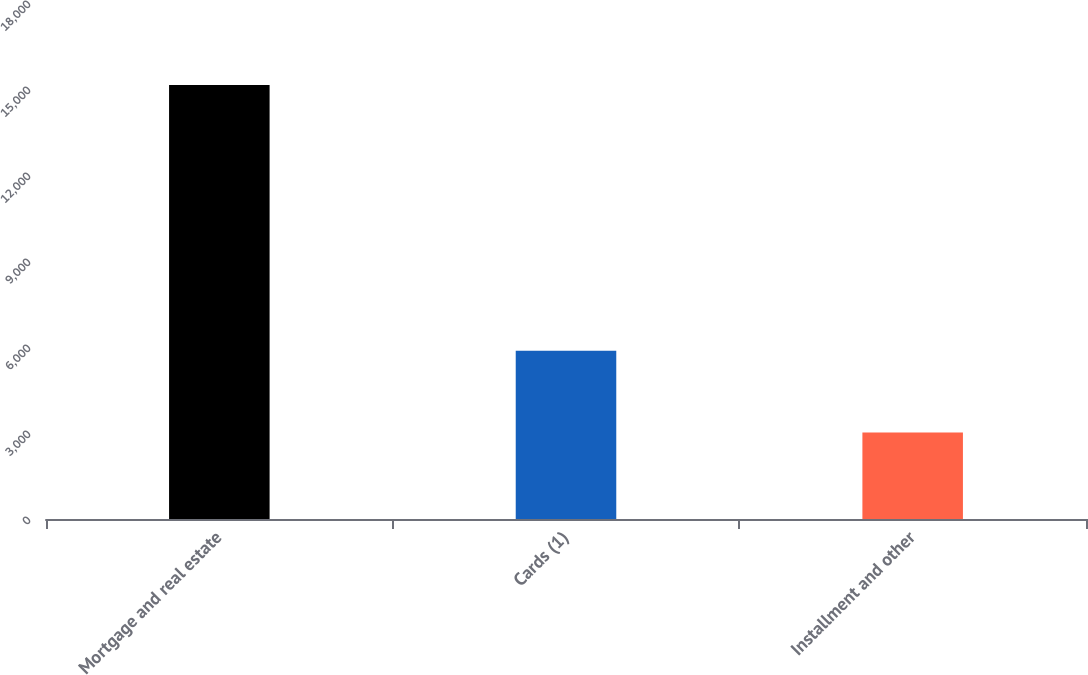Convert chart. <chart><loc_0><loc_0><loc_500><loc_500><bar_chart><fcel>Mortgage and real estate<fcel>Cards (1)<fcel>Installment and other<nl><fcel>15140<fcel>5869<fcel>3015<nl></chart> 